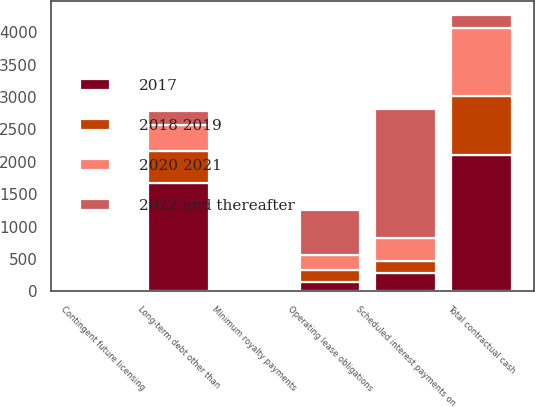<chart> <loc_0><loc_0><loc_500><loc_500><stacked_bar_chart><ecel><fcel>Operating lease obligations<fcel>Contingent future licensing<fcel>Minimum royalty payments<fcel>Scheduled interest payments on<fcel>Long-term debt other than<fcel>Total contractual cash<nl><fcel>2022 and thereafter<fcel>681.6<fcel>13.8<fcel>5.4<fcel>1993.1<fcel>213<fcel>213<nl><fcel>2018 2019<fcel>189.5<fcel>3.9<fcel>0.9<fcel>187.5<fcel>500<fcel>919.5<nl><fcel>2020 2021<fcel>236.5<fcel>4.3<fcel>1.8<fcel>343<fcel>400<fcel>1040.8<nl><fcel>2017<fcel>140.3<fcel>4.2<fcel>1.8<fcel>285.5<fcel>1665<fcel>2099.9<nl></chart> 